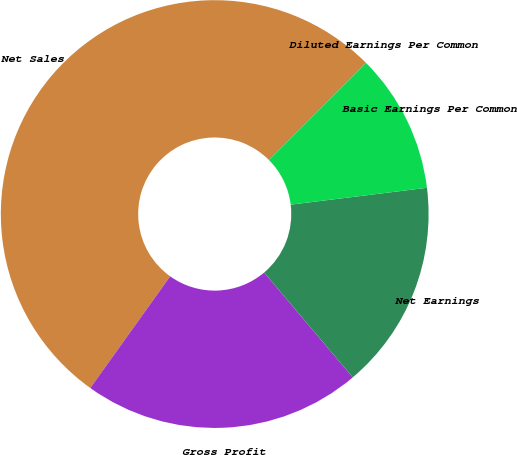Convert chart to OTSL. <chart><loc_0><loc_0><loc_500><loc_500><pie_chart><fcel>Net Sales<fcel>Gross Profit<fcel>Net Earnings<fcel>Basic Earnings Per Common<fcel>Diluted Earnings Per Common<nl><fcel>52.63%<fcel>21.05%<fcel>15.79%<fcel>10.53%<fcel>0.0%<nl></chart> 